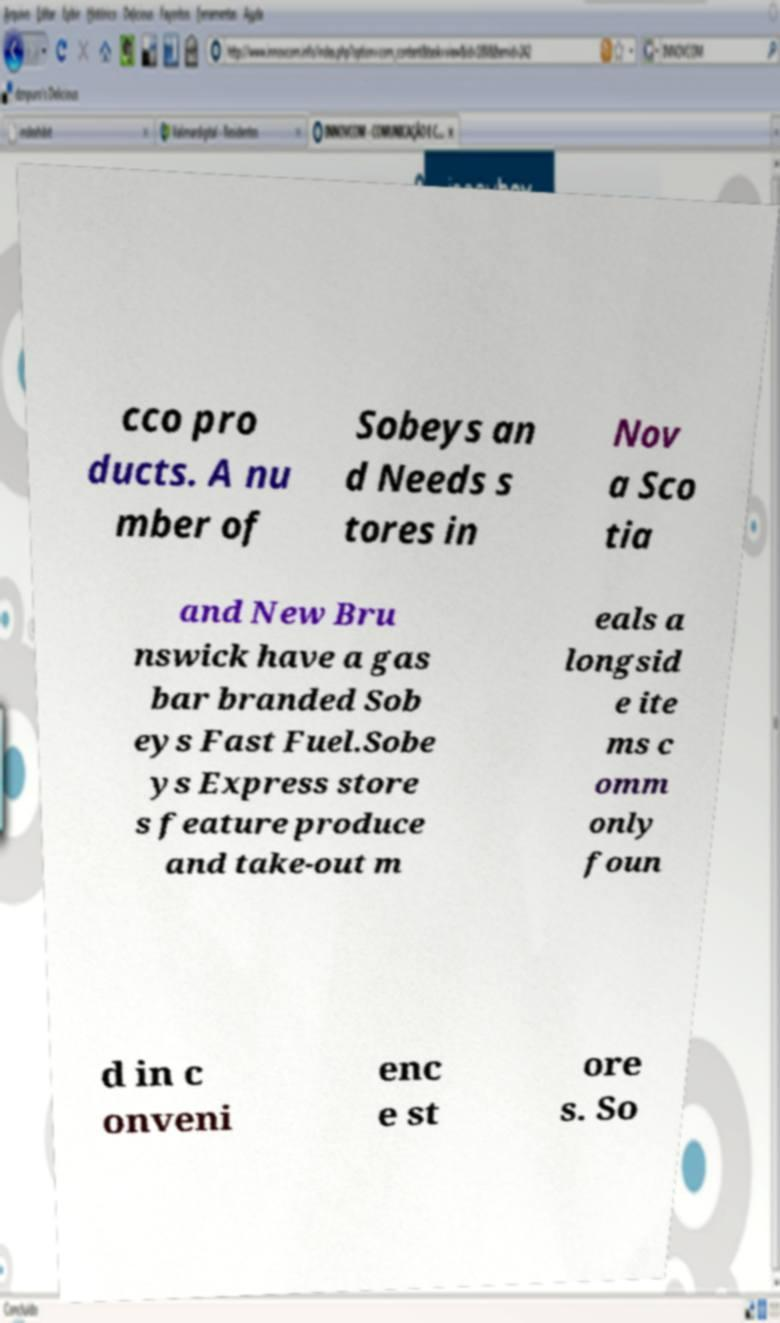For documentation purposes, I need the text within this image transcribed. Could you provide that? cco pro ducts. A nu mber of Sobeys an d Needs s tores in Nov a Sco tia and New Bru nswick have a gas bar branded Sob eys Fast Fuel.Sobe ys Express store s feature produce and take-out m eals a longsid e ite ms c omm only foun d in c onveni enc e st ore s. So 